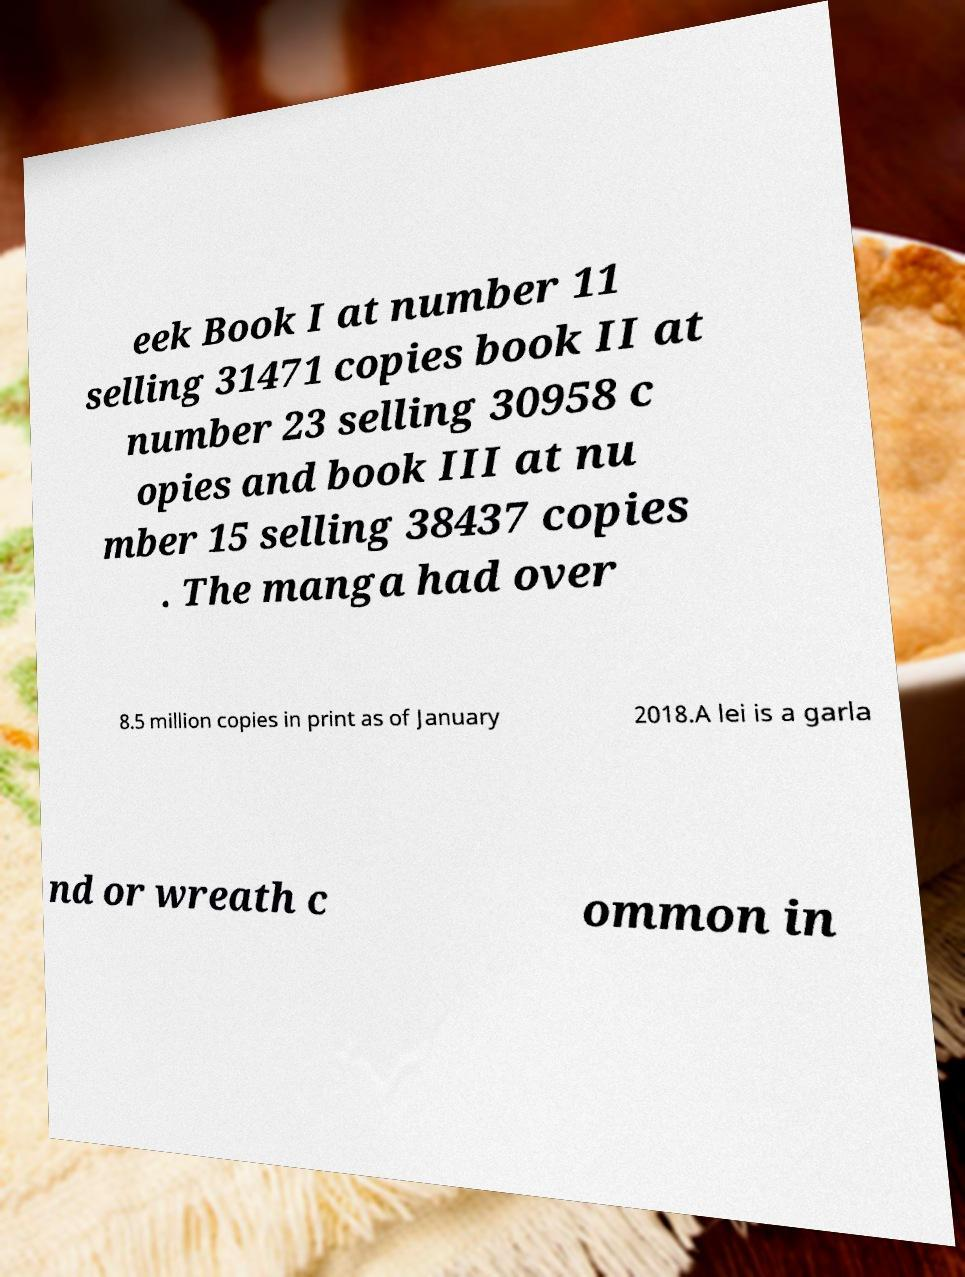Could you extract and type out the text from this image? eek Book I at number 11 selling 31471 copies book II at number 23 selling 30958 c opies and book III at nu mber 15 selling 38437 copies . The manga had over 8.5 million copies in print as of January 2018.A lei is a garla nd or wreath c ommon in 